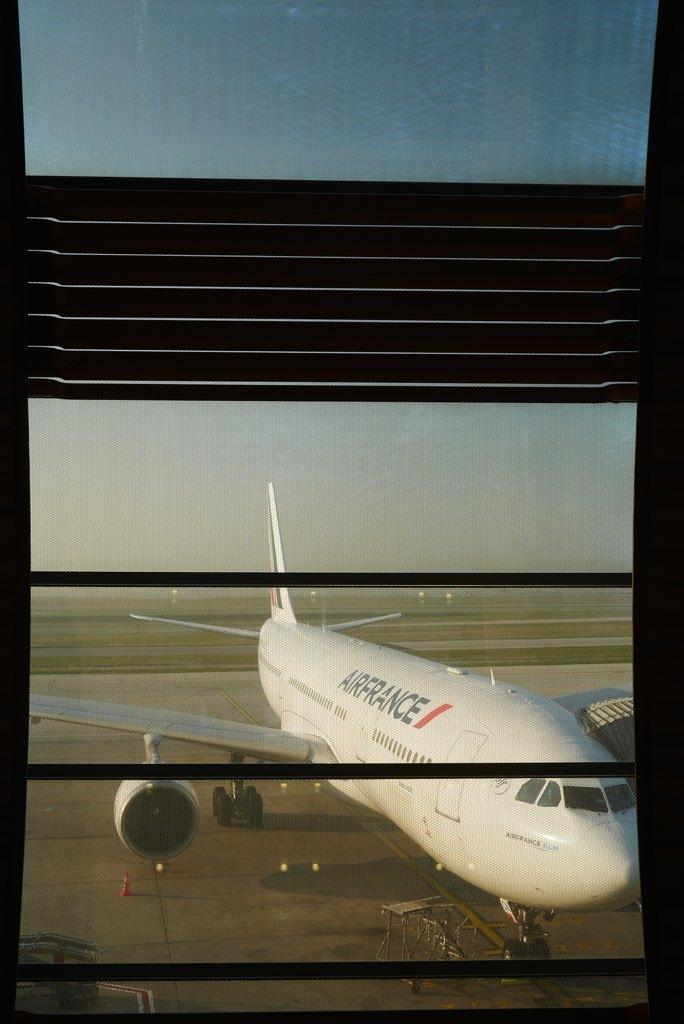<image>
Relay a brief, clear account of the picture shown. an Air France plane sitting on the runway 